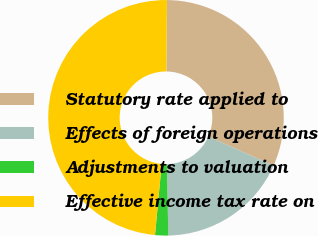Convert chart. <chart><loc_0><loc_0><loc_500><loc_500><pie_chart><fcel>Statutory rate applied to<fcel>Effects of foreign operations<fcel>Adjustments to valuation<fcel>Effective income tax rate on<nl><fcel>31.53%<fcel>18.02%<fcel>1.8%<fcel>48.65%<nl></chart> 